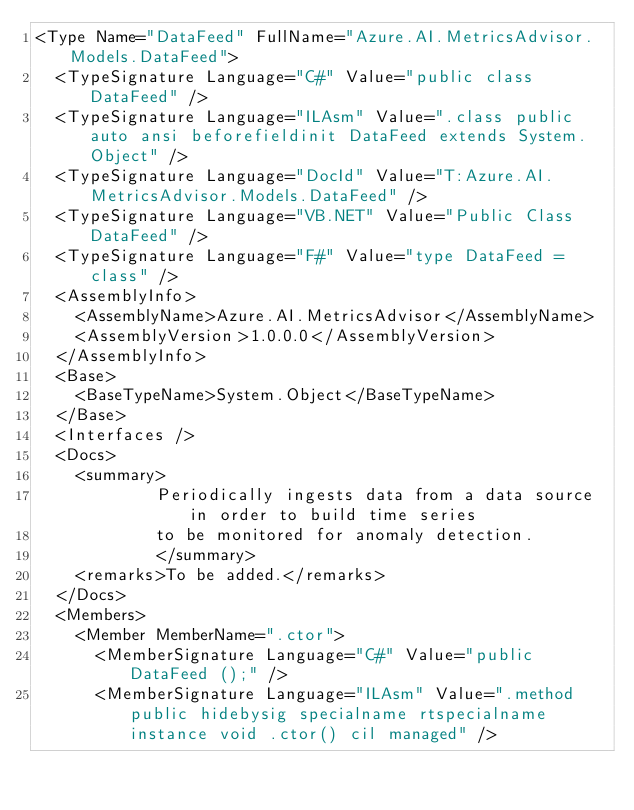Convert code to text. <code><loc_0><loc_0><loc_500><loc_500><_XML_><Type Name="DataFeed" FullName="Azure.AI.MetricsAdvisor.Models.DataFeed">
  <TypeSignature Language="C#" Value="public class DataFeed" />
  <TypeSignature Language="ILAsm" Value=".class public auto ansi beforefieldinit DataFeed extends System.Object" />
  <TypeSignature Language="DocId" Value="T:Azure.AI.MetricsAdvisor.Models.DataFeed" />
  <TypeSignature Language="VB.NET" Value="Public Class DataFeed" />
  <TypeSignature Language="F#" Value="type DataFeed = class" />
  <AssemblyInfo>
    <AssemblyName>Azure.AI.MetricsAdvisor</AssemblyName>
    <AssemblyVersion>1.0.0.0</AssemblyVersion>
  </AssemblyInfo>
  <Base>
    <BaseTypeName>System.Object</BaseTypeName>
  </Base>
  <Interfaces />
  <Docs>
    <summary>
            Periodically ingests data from a data source in order to build time series
            to be monitored for anomaly detection.
            </summary>
    <remarks>To be added.</remarks>
  </Docs>
  <Members>
    <Member MemberName=".ctor">
      <MemberSignature Language="C#" Value="public DataFeed ();" />
      <MemberSignature Language="ILAsm" Value=".method public hidebysig specialname rtspecialname instance void .ctor() cil managed" /></code> 